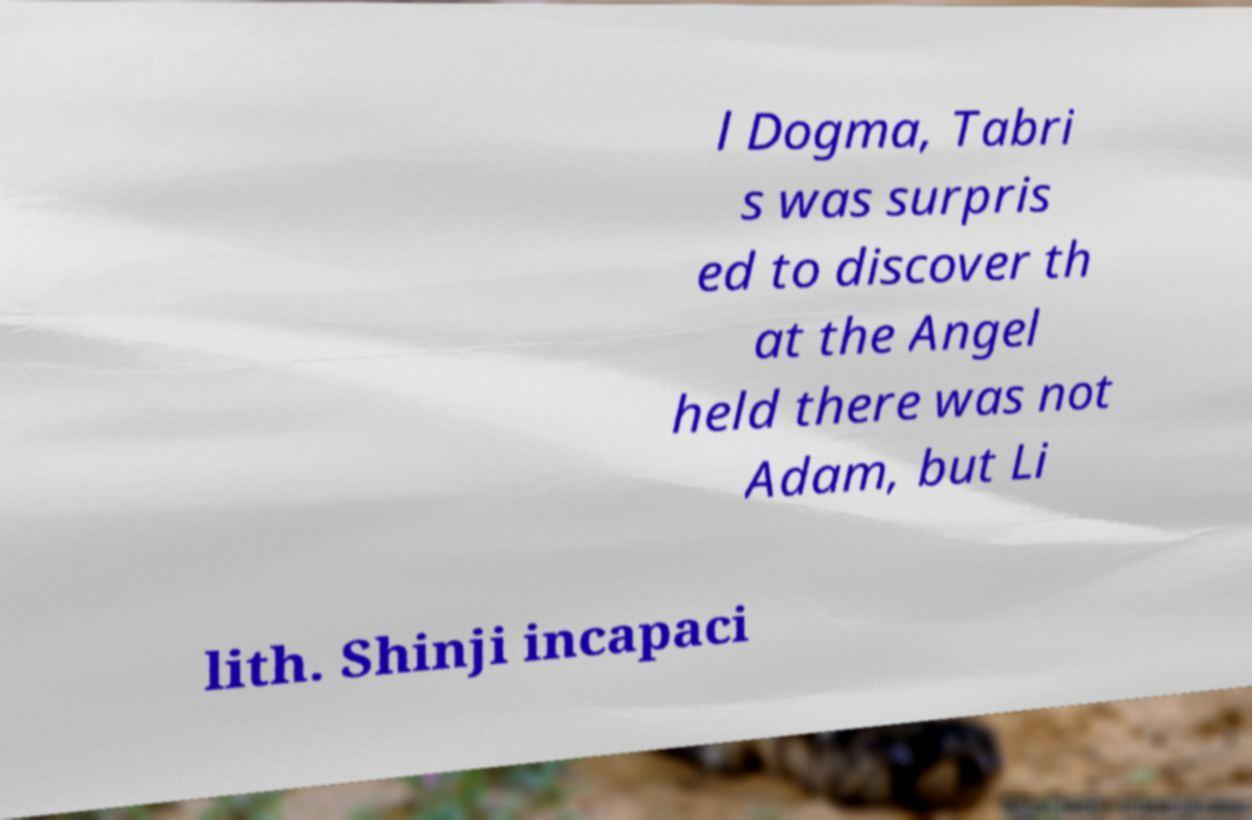Could you extract and type out the text from this image? l Dogma, Tabri s was surpris ed to discover th at the Angel held there was not Adam, but Li lith. Shinji incapaci 